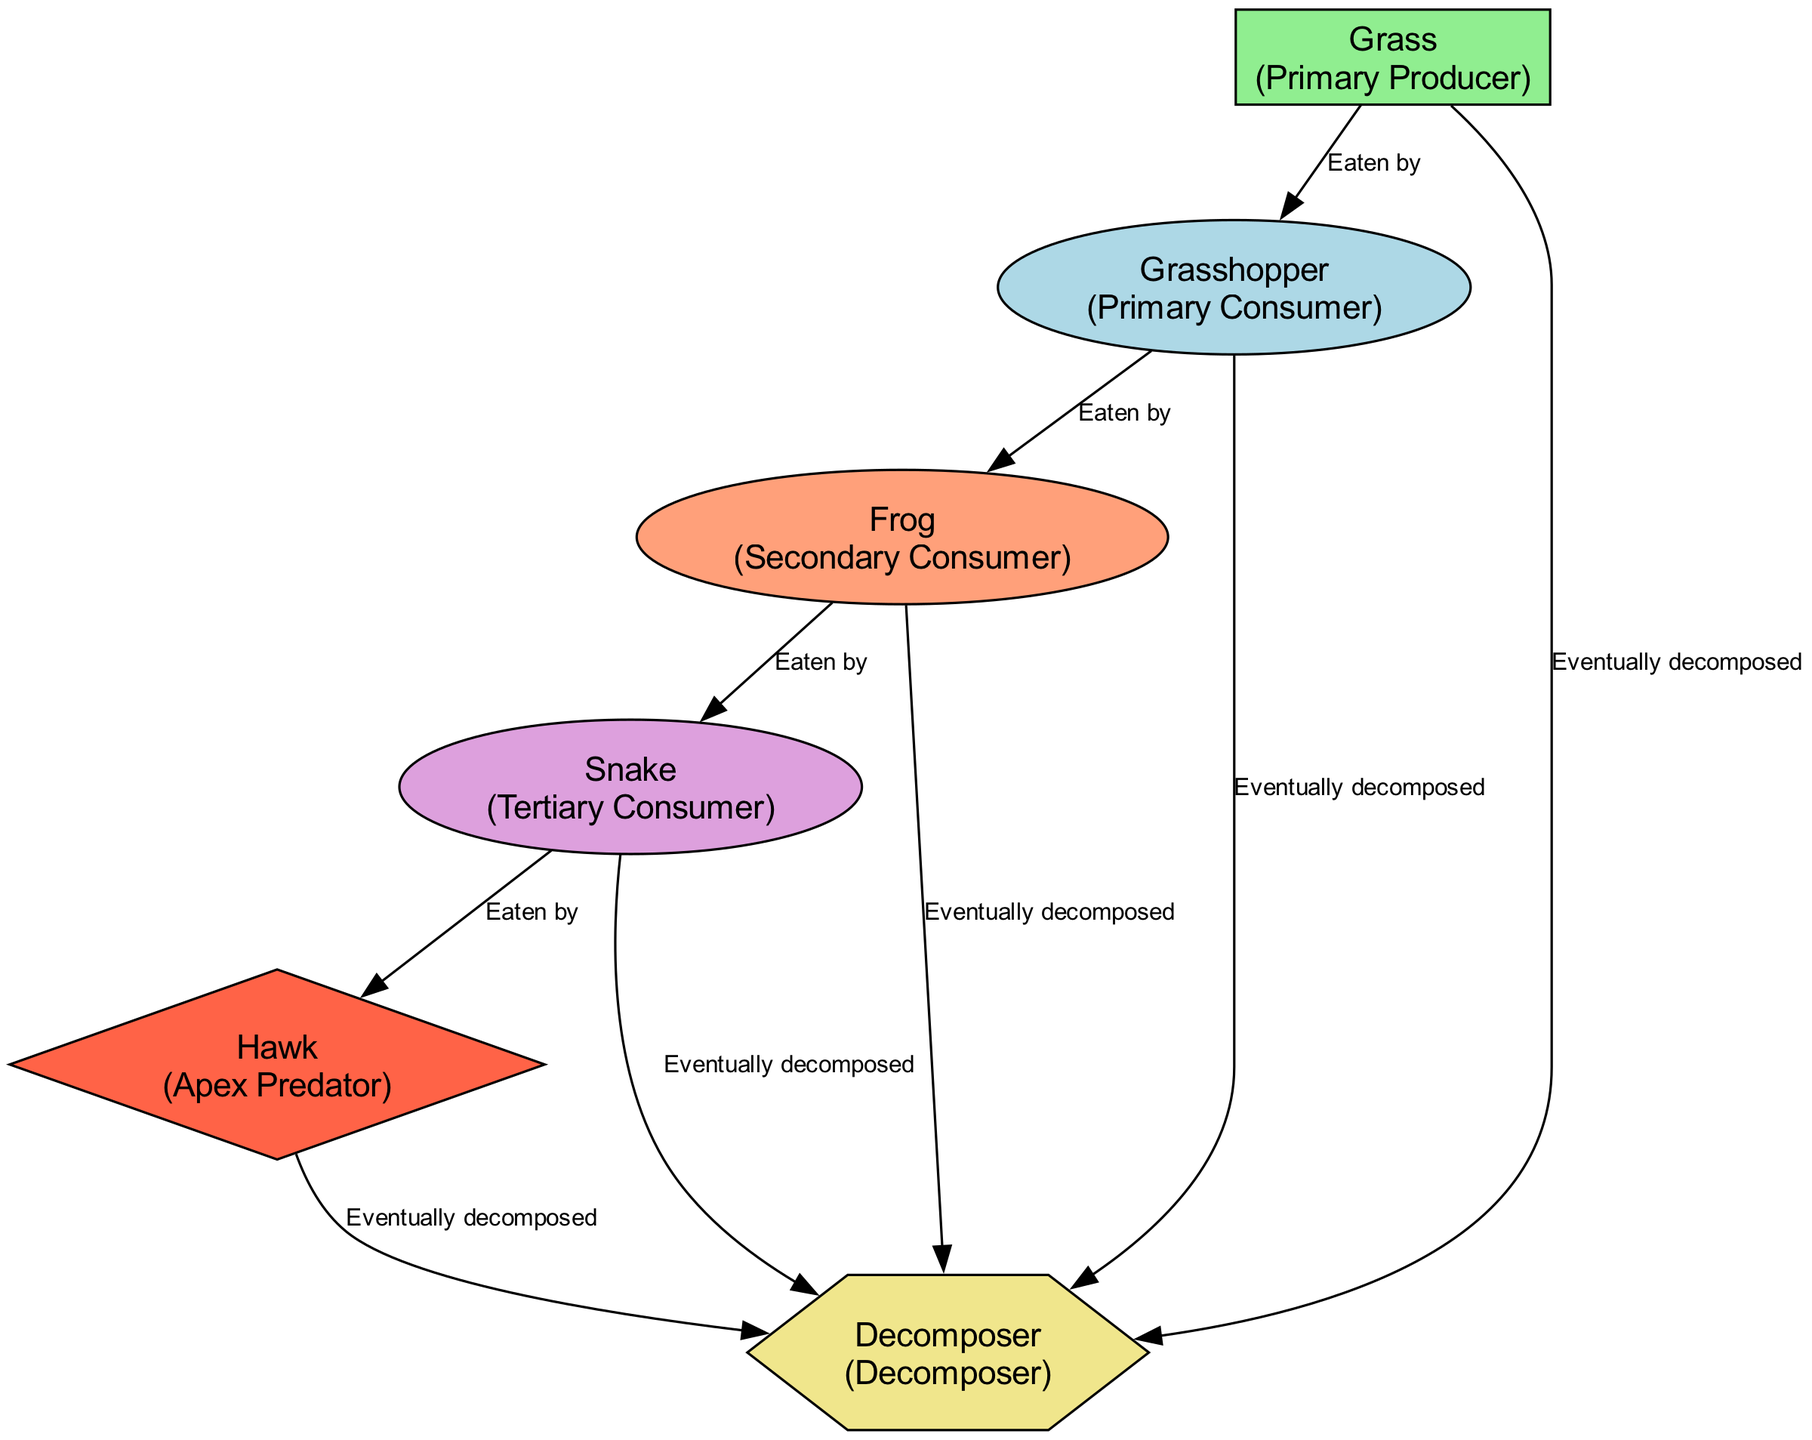What are the primary producers in the diagram? The diagram includes only one primary producer, which is grass. This is identified in the nodes where the type is listed as "Primary Producer."
Answer: Grass How many consumers are present in the diagram? By examining the nodes, there are three consumers: the grasshopper (primary consumer), frog (secondary consumer), and snake (tertiary consumer). Thus, when counted, there are three consumers.
Answer: 3 Which organism does the hawk eat? In the diagram, the hawk is linked to the snake with the label "Eaten by," indicating that the hawk preys on the snake. Therefore, the direct linkage shows that the hawk eats the snake.
Answer: Snake What type of organism decomposes the grass? Grass is identified as a primary producer in the diagram, and it is connected to the decomposer with the label "Eventually decomposed." Thus, the decomposer acts on the grass, breaking it down after its life cycle.
Answer: Decomposer How many edges are there in the diagram? Looking at the edges, we can count each connection between nodes. There are eight edges total that illustrate the relationships among the nodes in the food chain.
Answer: 8 Which organism is at the top of the food chain? The apex predator, characterized as the highest level in the food chain, is the hawk, as indicated by its position without any predators above it in the diagram.
Answer: Hawk How is energy transferred from grass to frogs? The energy transfer from grass to frogs occurs through the grasshopper, which consumes grass and is then eaten by the frog, indicating a flow of energy from the primary producer through the primary consumer to the secondary consumer.
Answer: Grasshopper What is the role of the decomposer in this ecosystem? The decomposer contributes by breaking down dead organisms, as indicated in multiple connections to various organisms, including the hawk, snake, frog, grasshopper, and grass, illustrating its essential role in recycling nutrients back into the ecosystem.
Answer: Breaks down dead organisms 